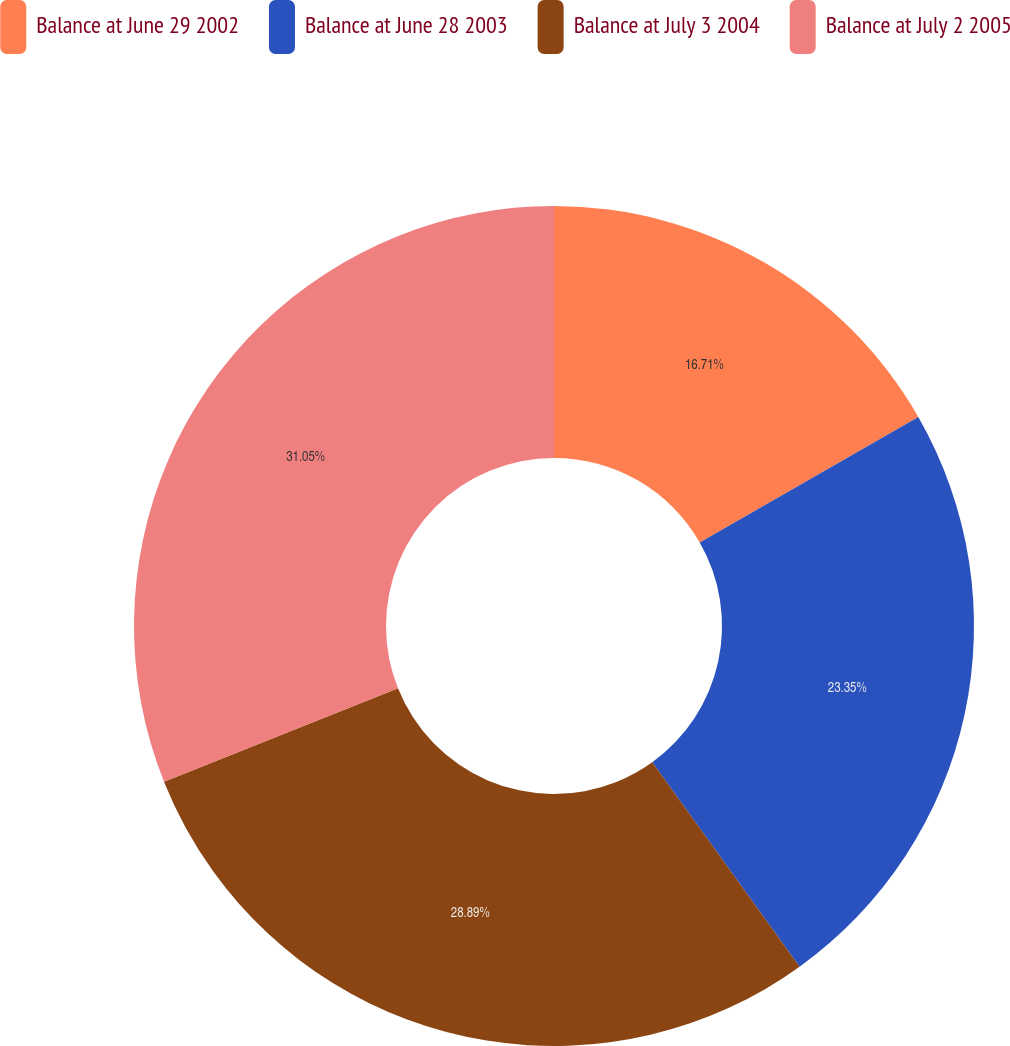Convert chart. <chart><loc_0><loc_0><loc_500><loc_500><pie_chart><fcel>Balance at June 29 2002<fcel>Balance at June 28 2003<fcel>Balance at July 3 2004<fcel>Balance at July 2 2005<nl><fcel>16.71%<fcel>23.35%<fcel>28.89%<fcel>31.05%<nl></chart> 